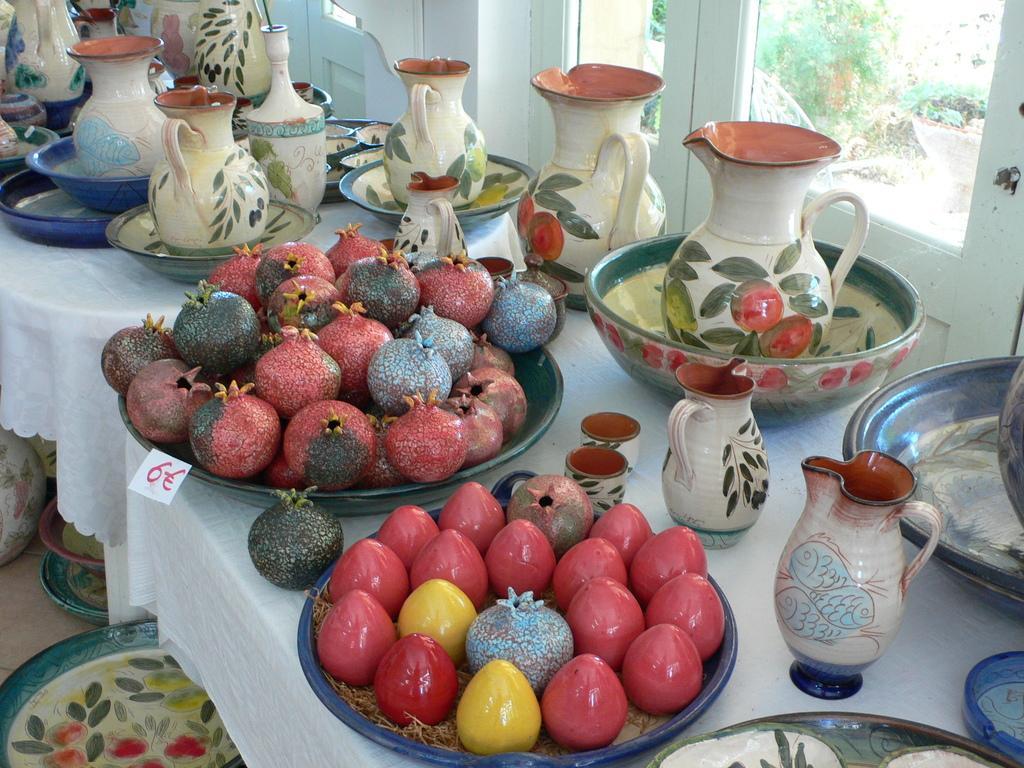In one or two sentences, can you explain what this image depicts? there is a table with the painted pomegranates and kiwis and a jar in a bowl. 